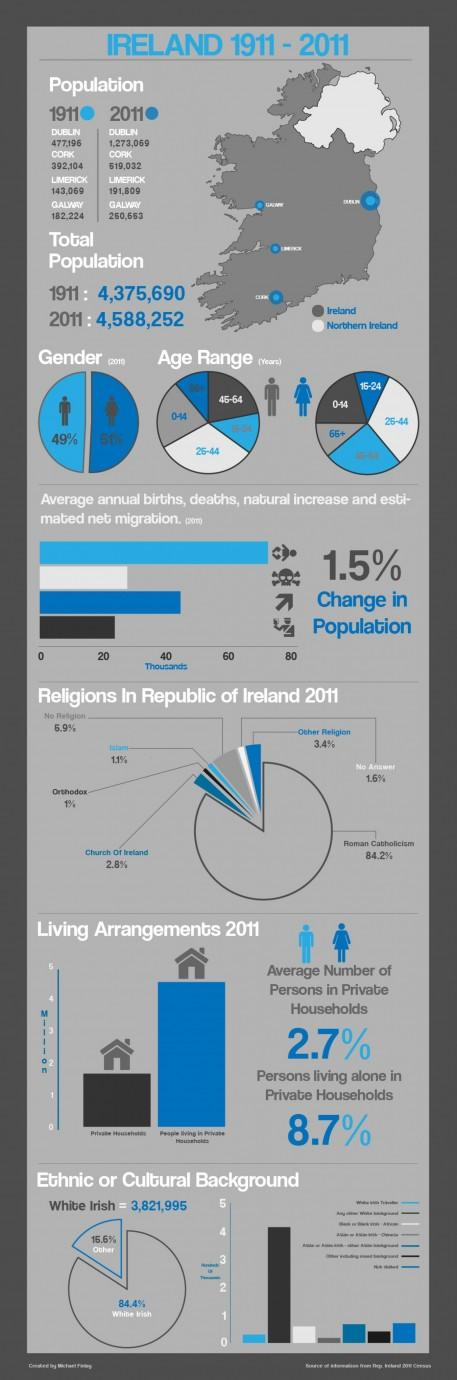Identify some key points in this picture. According to data from 1911, the population of Limerick City was 143,069. The population of Cork city in Ireland in 1911 was 392,104. In 2011, the population of Dublin was estimated to be 1,273,069. In 2011, the male population in Ireland accounted for 49% of the total population. In 2011, it was reported that 84.2% of the population in Ireland identified as Roman Catholic. 